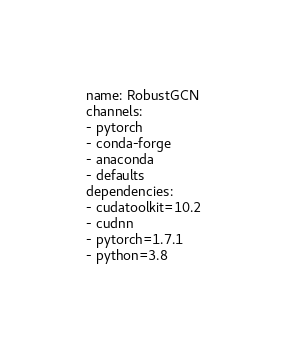Convert code to text. <code><loc_0><loc_0><loc_500><loc_500><_YAML_>name: RobustGCN
channels:
- pytorch
- conda-forge
- anaconda
- defaults
dependencies:
- cudatoolkit=10.2
- cudnn
- pytorch=1.7.1
- python=3.8</code> 